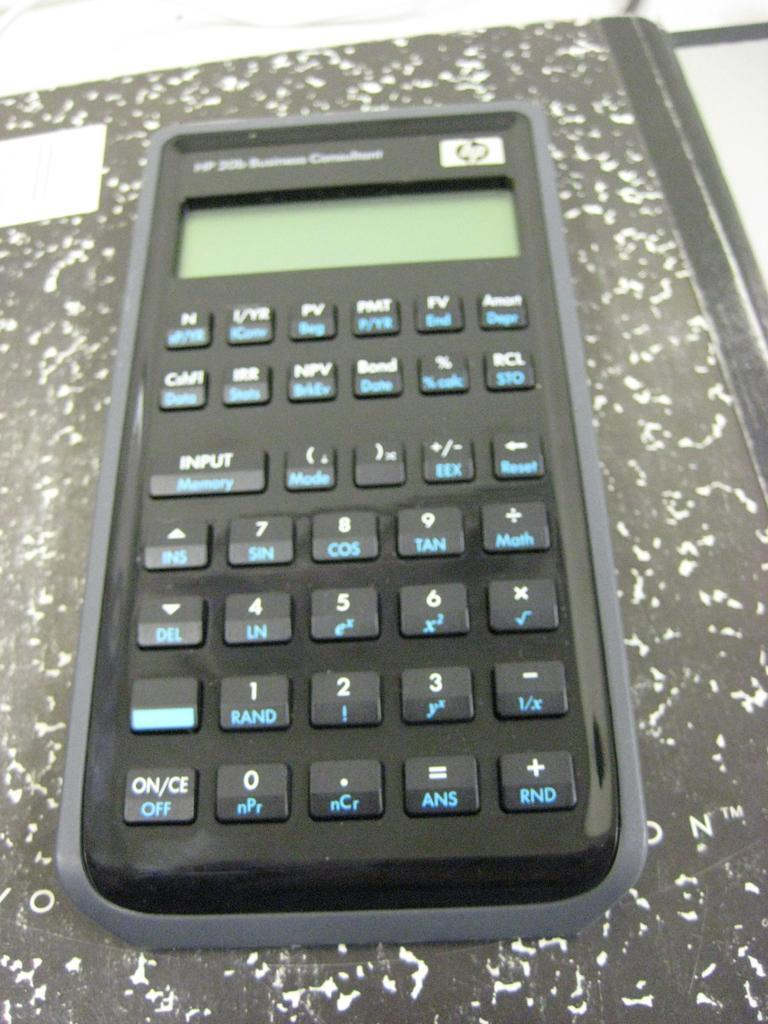<image>
Render a clear and concise summary of the photo. Black HP calculator with blue buttons on top of a notebook. 